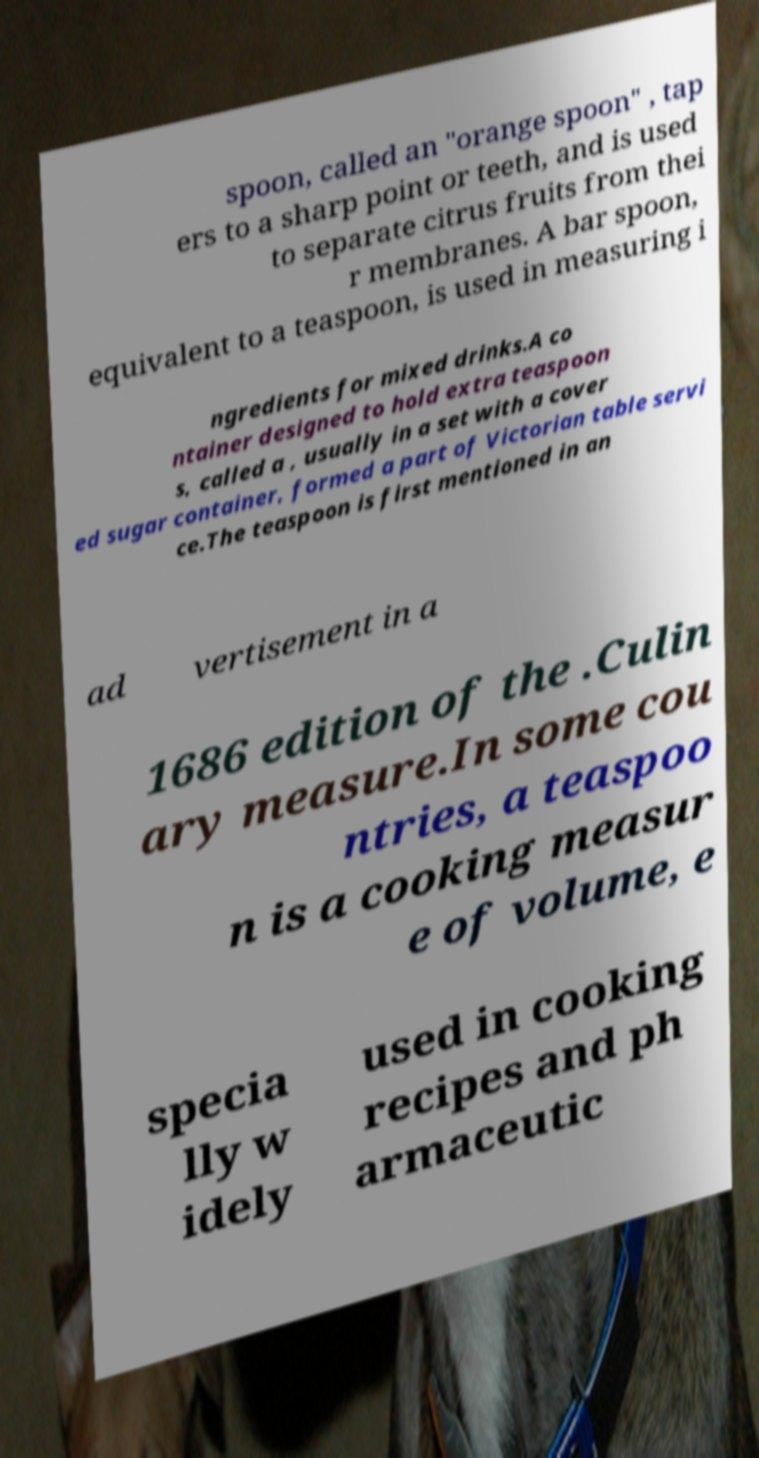Can you read and provide the text displayed in the image?This photo seems to have some interesting text. Can you extract and type it out for me? spoon, called an "orange spoon" , tap ers to a sharp point or teeth, and is used to separate citrus fruits from thei r membranes. A bar spoon, equivalent to a teaspoon, is used in measuring i ngredients for mixed drinks.A co ntainer designed to hold extra teaspoon s, called a , usually in a set with a cover ed sugar container, formed a part of Victorian table servi ce.The teaspoon is first mentioned in an ad vertisement in a 1686 edition of the .Culin ary measure.In some cou ntries, a teaspoo n is a cooking measur e of volume, e specia lly w idely used in cooking recipes and ph armaceutic 